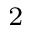<formula> <loc_0><loc_0><loc_500><loc_500>^ { 2 }</formula> 